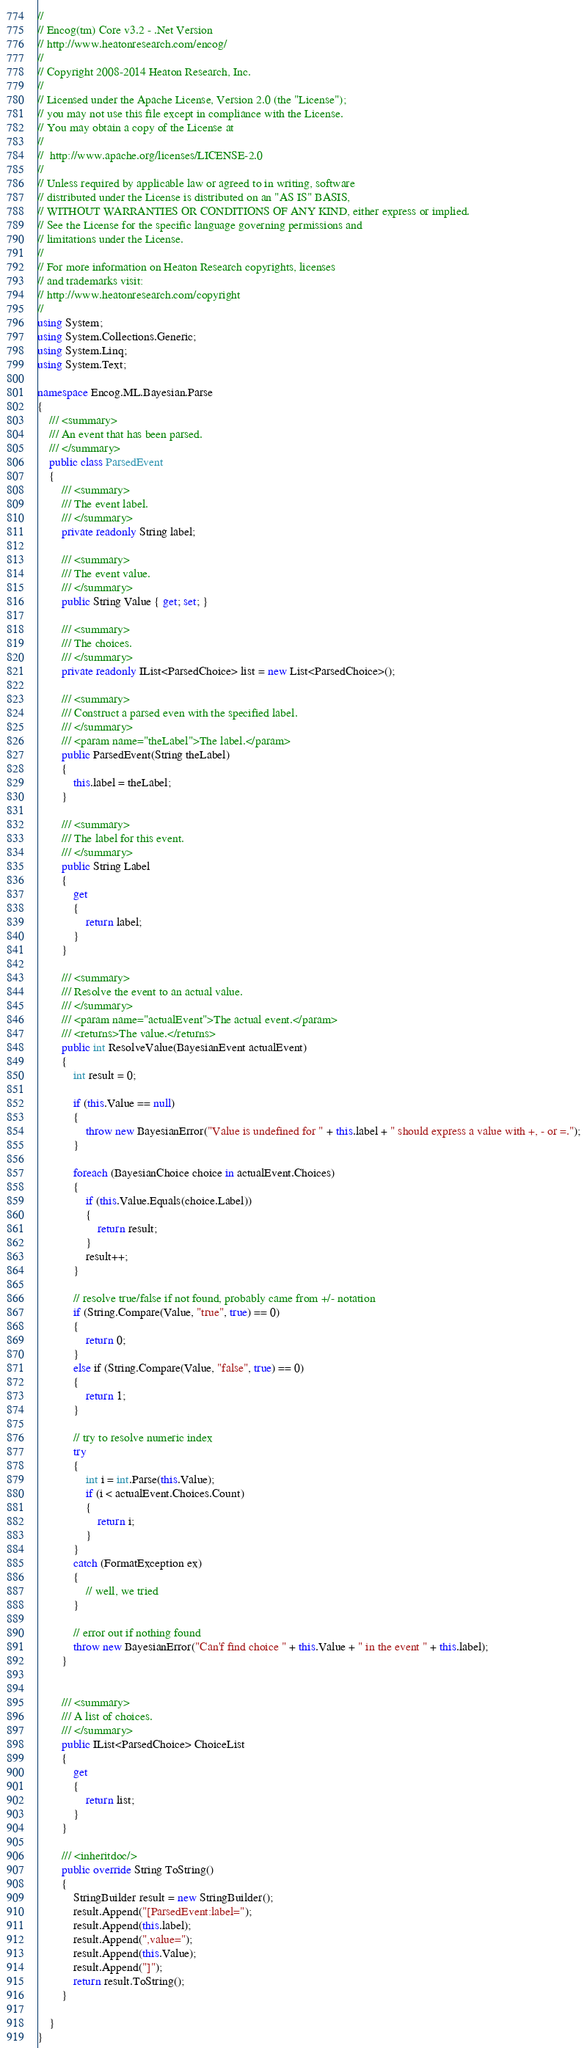<code> <loc_0><loc_0><loc_500><loc_500><_C#_>//
// Encog(tm) Core v3.2 - .Net Version
// http://www.heatonresearch.com/encog/
//
// Copyright 2008-2014 Heaton Research, Inc.
//
// Licensed under the Apache License, Version 2.0 (the "License");
// you may not use this file except in compliance with the License.
// You may obtain a copy of the License at
//
//  http://www.apache.org/licenses/LICENSE-2.0
//
// Unless required by applicable law or agreed to in writing, software
// distributed under the License is distributed on an "AS IS" BASIS,
// WITHOUT WARRANTIES OR CONDITIONS OF ANY KIND, either express or implied.
// See the License for the specific language governing permissions and
// limitations under the License.
//   
// For more information on Heaton Research copyrights, licenses 
// and trademarks visit:
// http://www.heatonresearch.com/copyright
//
using System;
using System.Collections.Generic;
using System.Linq;
using System.Text;

namespace Encog.ML.Bayesian.Parse
{
    /// <summary>
    /// An event that has been parsed.
    /// </summary>
    public class ParsedEvent
    {
        /// <summary>
        /// The event label.
        /// </summary>
        private readonly String label;

        /// <summary>
        /// The event value.
        /// </summary>
        public String Value { get; set; }

        /// <summary>
        /// The choices.
        /// </summary>
        private readonly IList<ParsedChoice> list = new List<ParsedChoice>();

        /// <summary>
        /// Construct a parsed even with the specified label.
        /// </summary>
        /// <param name="theLabel">The label.</param>
        public ParsedEvent(String theLabel)
        {
            this.label = theLabel;
        }

        /// <summary>
        /// The label for this event.
        /// </summary>
        public String Label
        {
            get
            {
                return label;
            }
        }

        /// <summary>
        /// Resolve the event to an actual value.
        /// </summary>
        /// <param name="actualEvent">The actual event.</param>
        /// <returns>The value.</returns>
        public int ResolveValue(BayesianEvent actualEvent)
        {
            int result = 0;

            if (this.Value == null)
            {
                throw new BayesianError("Value is undefined for " + this.label + " should express a value with +, - or =.");
            }

            foreach (BayesianChoice choice in actualEvent.Choices)
            {
                if (this.Value.Equals(choice.Label))
                {
                    return result;
                }
                result++;
            }

            // resolve true/false if not found, probably came from +/- notation
            if (String.Compare(Value, "true", true) == 0)
            {
                return 0;
            }
            else if (String.Compare(Value, "false", true) == 0)
            {
                return 1;
            }

            // try to resolve numeric index
            try
            {
                int i = int.Parse(this.Value);
                if (i < actualEvent.Choices.Count)
                {
                    return i;
                }
            }
            catch (FormatException ex)
            {
                // well, we tried
            }

            // error out if nothing found
            throw new BayesianError("Can'f find choice " + this.Value + " in the event " + this.label);
        }


        /// <summary>
        /// A list of choices.
        /// </summary>
        public IList<ParsedChoice> ChoiceList
        {
            get
            {
                return list;
            }
        }

        /// <inheritdoc/>
        public override String ToString()
        {
            StringBuilder result = new StringBuilder();
            result.Append("[ParsedEvent:label=");
            result.Append(this.label);
            result.Append(",value=");
            result.Append(this.Value);
            result.Append("]");
            return result.ToString();
        }

    }
}
</code> 